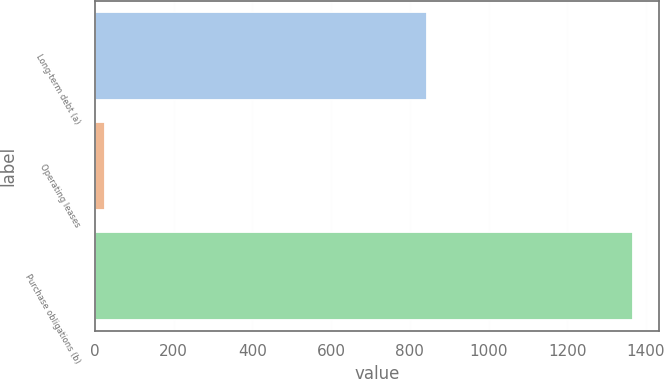Convert chart to OTSL. <chart><loc_0><loc_0><loc_500><loc_500><bar_chart><fcel>Long-term debt (a)<fcel>Operating leases<fcel>Purchase obligations (b)<nl><fcel>843<fcel>24<fcel>1366<nl></chart> 